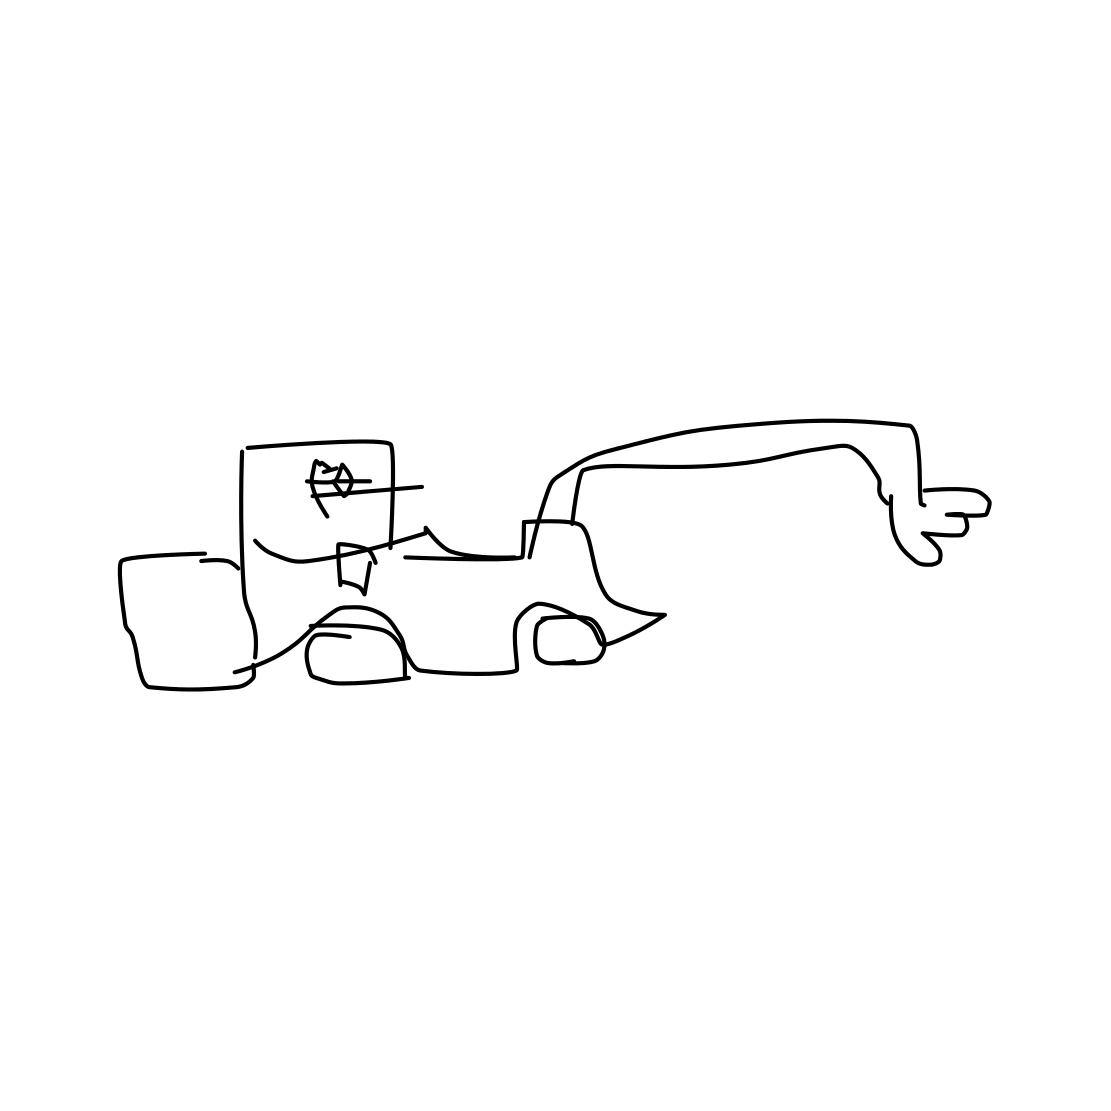Could you describe the style of drawing used in this image? This image is drawn in a minimalistic style, utilizing simple lines and shapes without considerable detail to suggest the form of a car. What can you tell about the artist's intention based on this style? The artist may have intended for a playful or abstract interpretation, focusing on conveying the concept of a car with minimal visual elements, or it could be a deliberate choice to showcase artistic simplicity and open-ended engagement. 